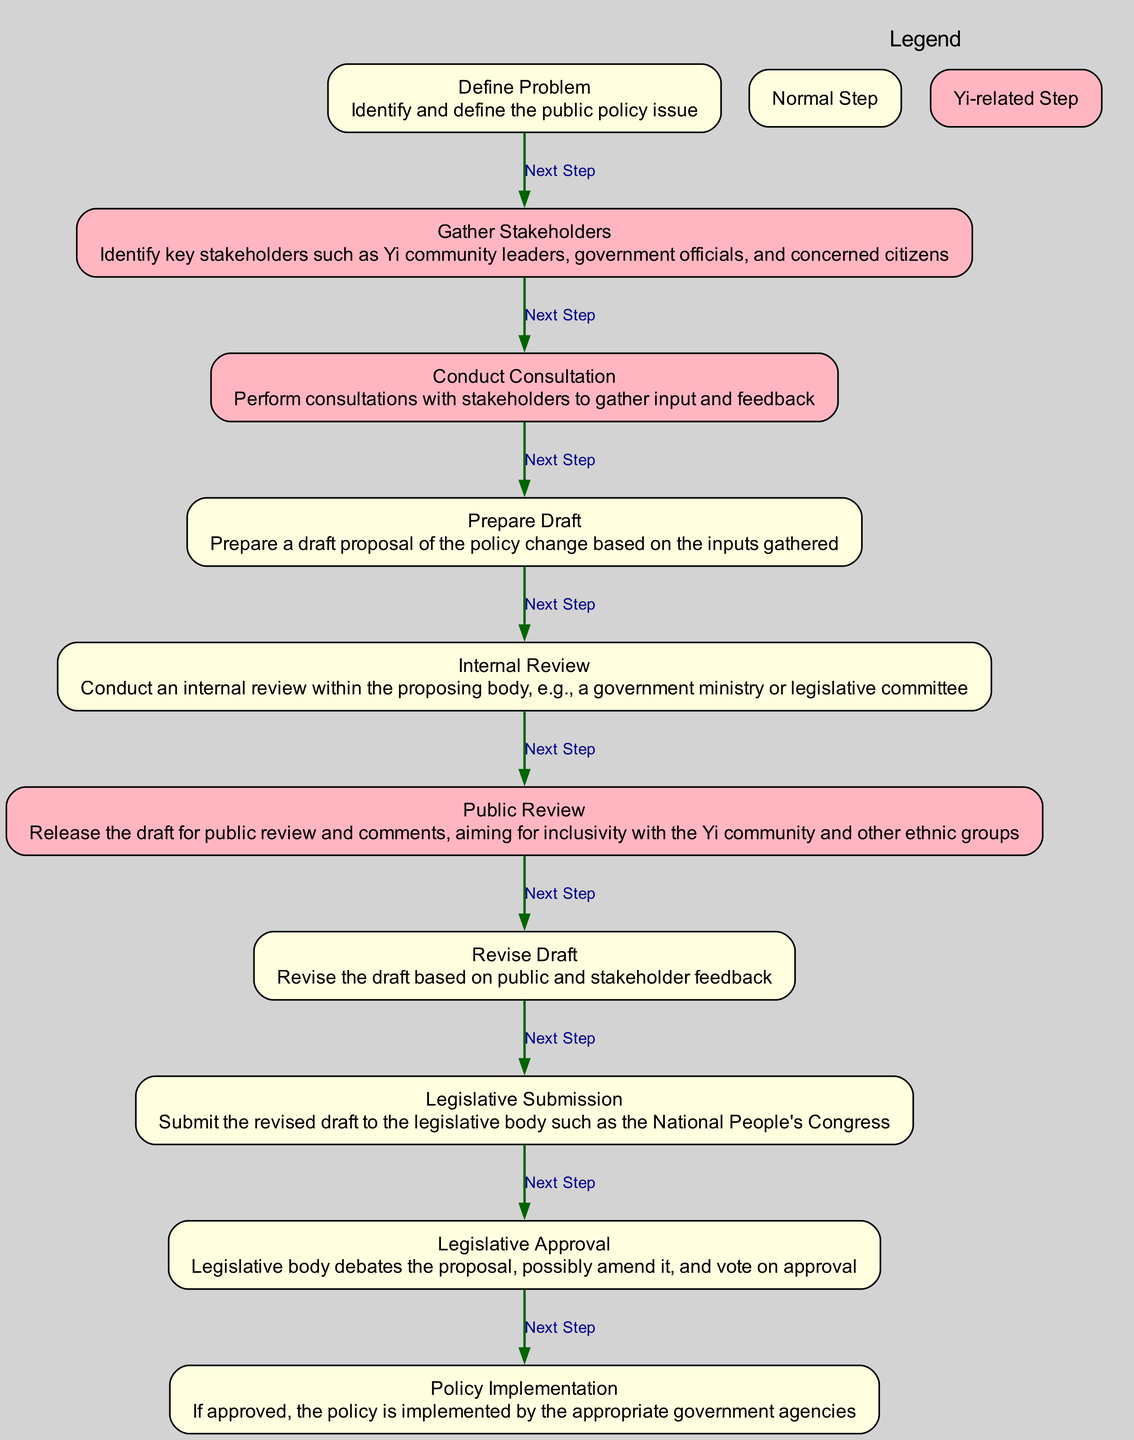What is the first step in the process? The first step is identified by the node "define_problem", which indicates that the public policy issue must be identified and defined before any further actions can be taken.
Answer: Identify and define the public policy issue How many main steps are there in the policy change process? To determine the number of main steps, we count the elements in the diagram. There are a total of 10 steps listed from "define_problem" to "policy_implementation".
Answer: 10 Which stakeholders are primarily involved in the consultation? The consultation process draws upon the inputs of key stakeholders, specifically mentioning 'Yi community leaders, government officials, and concerned citizens' as important participants.
Answer: Yi community leaders, government officials, and concerned citizens What follows the internal review step? By looking at the edge leading from "internal_review", we see that the next step is "public_review", which indicates that public input and reactions are involved after the internal assessments have been completed.
Answer: Public review Which step emphasizes inclusivity with the Yi community? The step that emphasizes inclusivity with the Yi community is "public_review", where the draft is released for public comments, specifically aiming for inclusiveness with various ethnic groups, including the Yi community.
Answer: Public review How many steps include stakeholder input? By analyzing the diagram, stakeholder input is formally incorporated in "gather_stakeholders", "conduct_consultation", and "revise_draft". This gives us a total of three steps that specifically involve stakeholder feedback.
Answer: 3 What type of steps are highlighted in pink? The nodes that are highlighted in pink relate to the Yi ethnicity, specifically indicating that these steps are particularly significant for the Yi community in the policy change process.
Answer: Yi-related Step What is the last step in the policy change process? The last node in the diagram is "policy_implementation", which signifies that if the proposal is approved, it will then be implemented by the appropriate government agencies, concluding the policy change process.
Answer: Policy implementation Which legislative body is mentioned for submission of the revised draft? The diagram specifies that the "legislative_submission" step involves submitting the draft to the "National People's Congress", indicating the legislative body pertinent to this process.
Answer: National People's Congress What happens during the legislative approval step? In the "legislative_approval" step, the legislative body debates the proposal, may amend it, and conducts a vote on whether to approve the proposed policy change.
Answer: Legislative body debates the proposal, possibly amend it, and vote on approval 